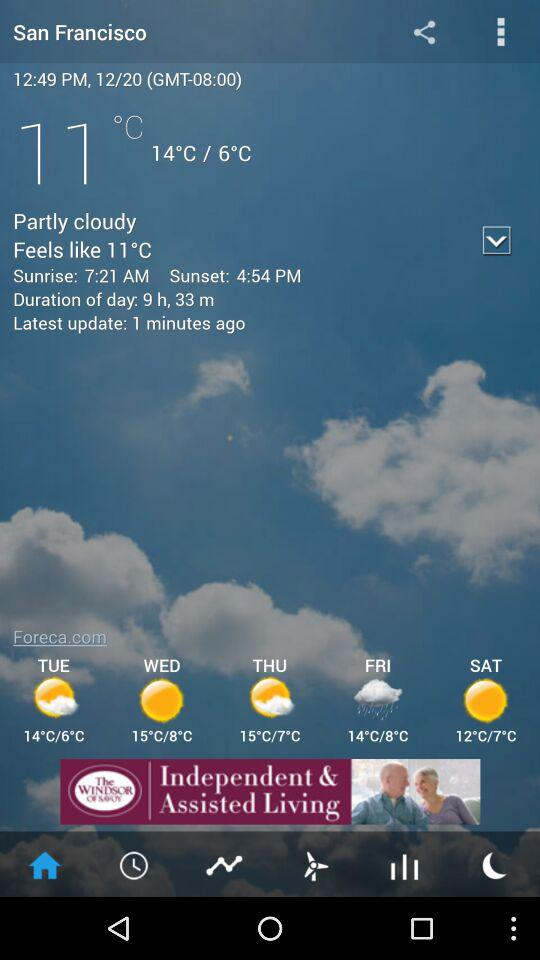What is the time of sunset? The time of sunset is 4:54 PM. 